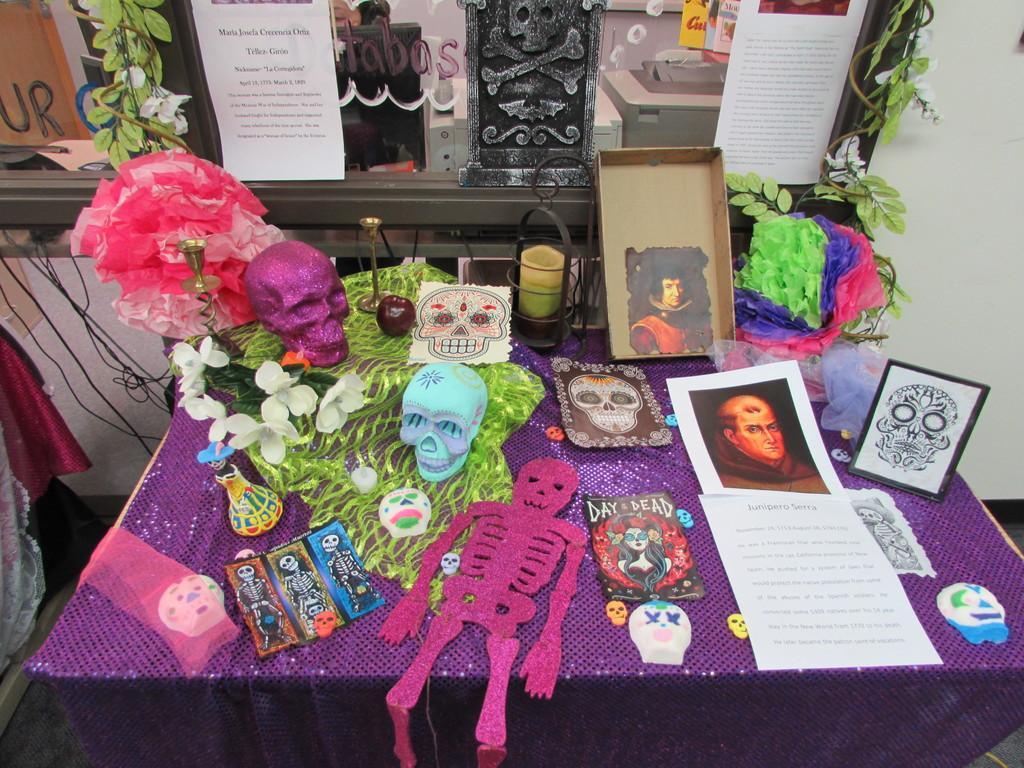Describe this image in one or two sentences. In this picture we can see a table in the front, there are two papers, some paper arts, skulls, a box, a frame, clothes present on the table, on the right side we can see leaves, in the background there are papers pasted, on the left side there are wires, we can see a wall on the right side. 